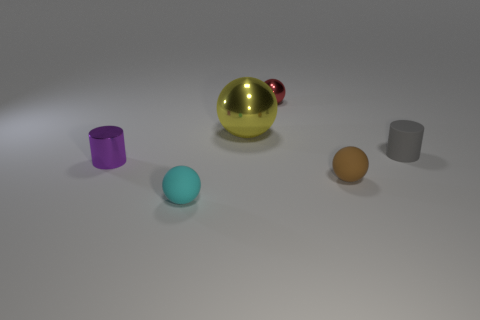Describe the lighting in the image. Where does it appear to be coming from? The lighting in the image is soft and diffuse, suggesting an overcast or studio lighting setup. It appears to be coming from above as indicated by subtle shadows directly under the objects. 